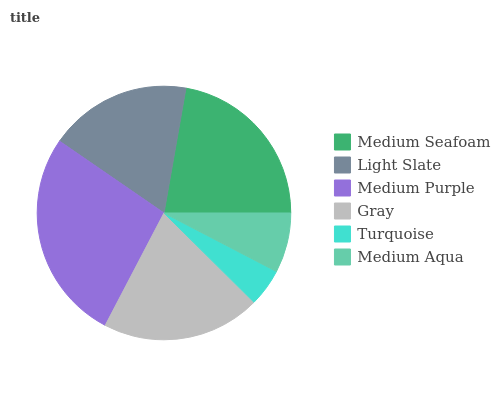Is Turquoise the minimum?
Answer yes or no. Yes. Is Medium Purple the maximum?
Answer yes or no. Yes. Is Light Slate the minimum?
Answer yes or no. No. Is Light Slate the maximum?
Answer yes or no. No. Is Medium Seafoam greater than Light Slate?
Answer yes or no. Yes. Is Light Slate less than Medium Seafoam?
Answer yes or no. Yes. Is Light Slate greater than Medium Seafoam?
Answer yes or no. No. Is Medium Seafoam less than Light Slate?
Answer yes or no. No. Is Gray the high median?
Answer yes or no. Yes. Is Light Slate the low median?
Answer yes or no. Yes. Is Light Slate the high median?
Answer yes or no. No. Is Medium Aqua the low median?
Answer yes or no. No. 